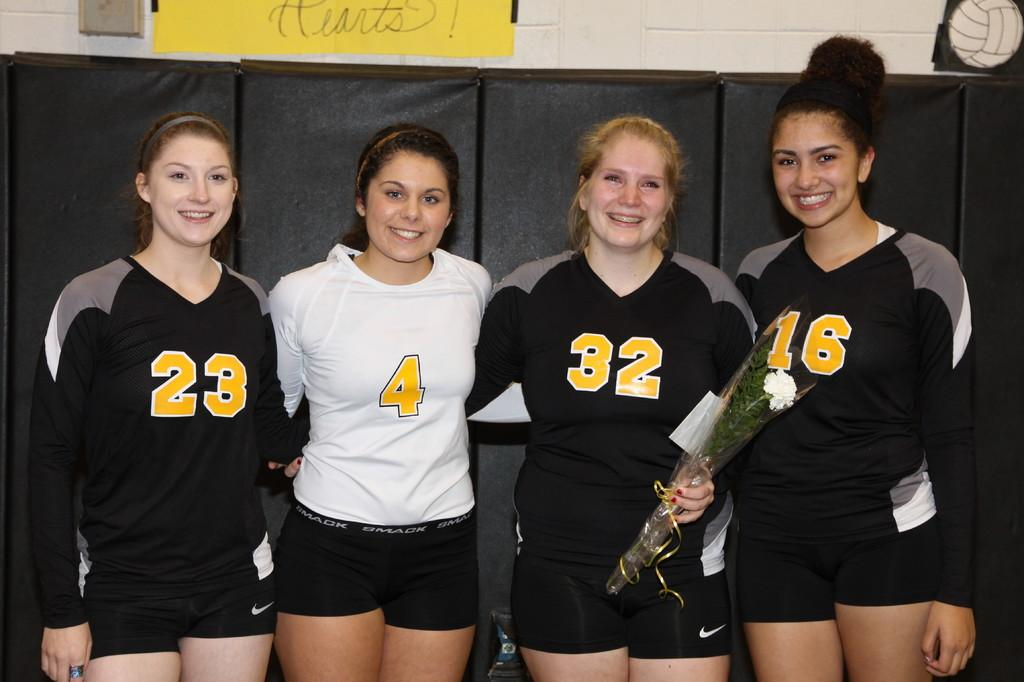<image>
Write a terse but informative summary of the picture. four women athletes lined up wearing numbered shirts like 23 and 4 